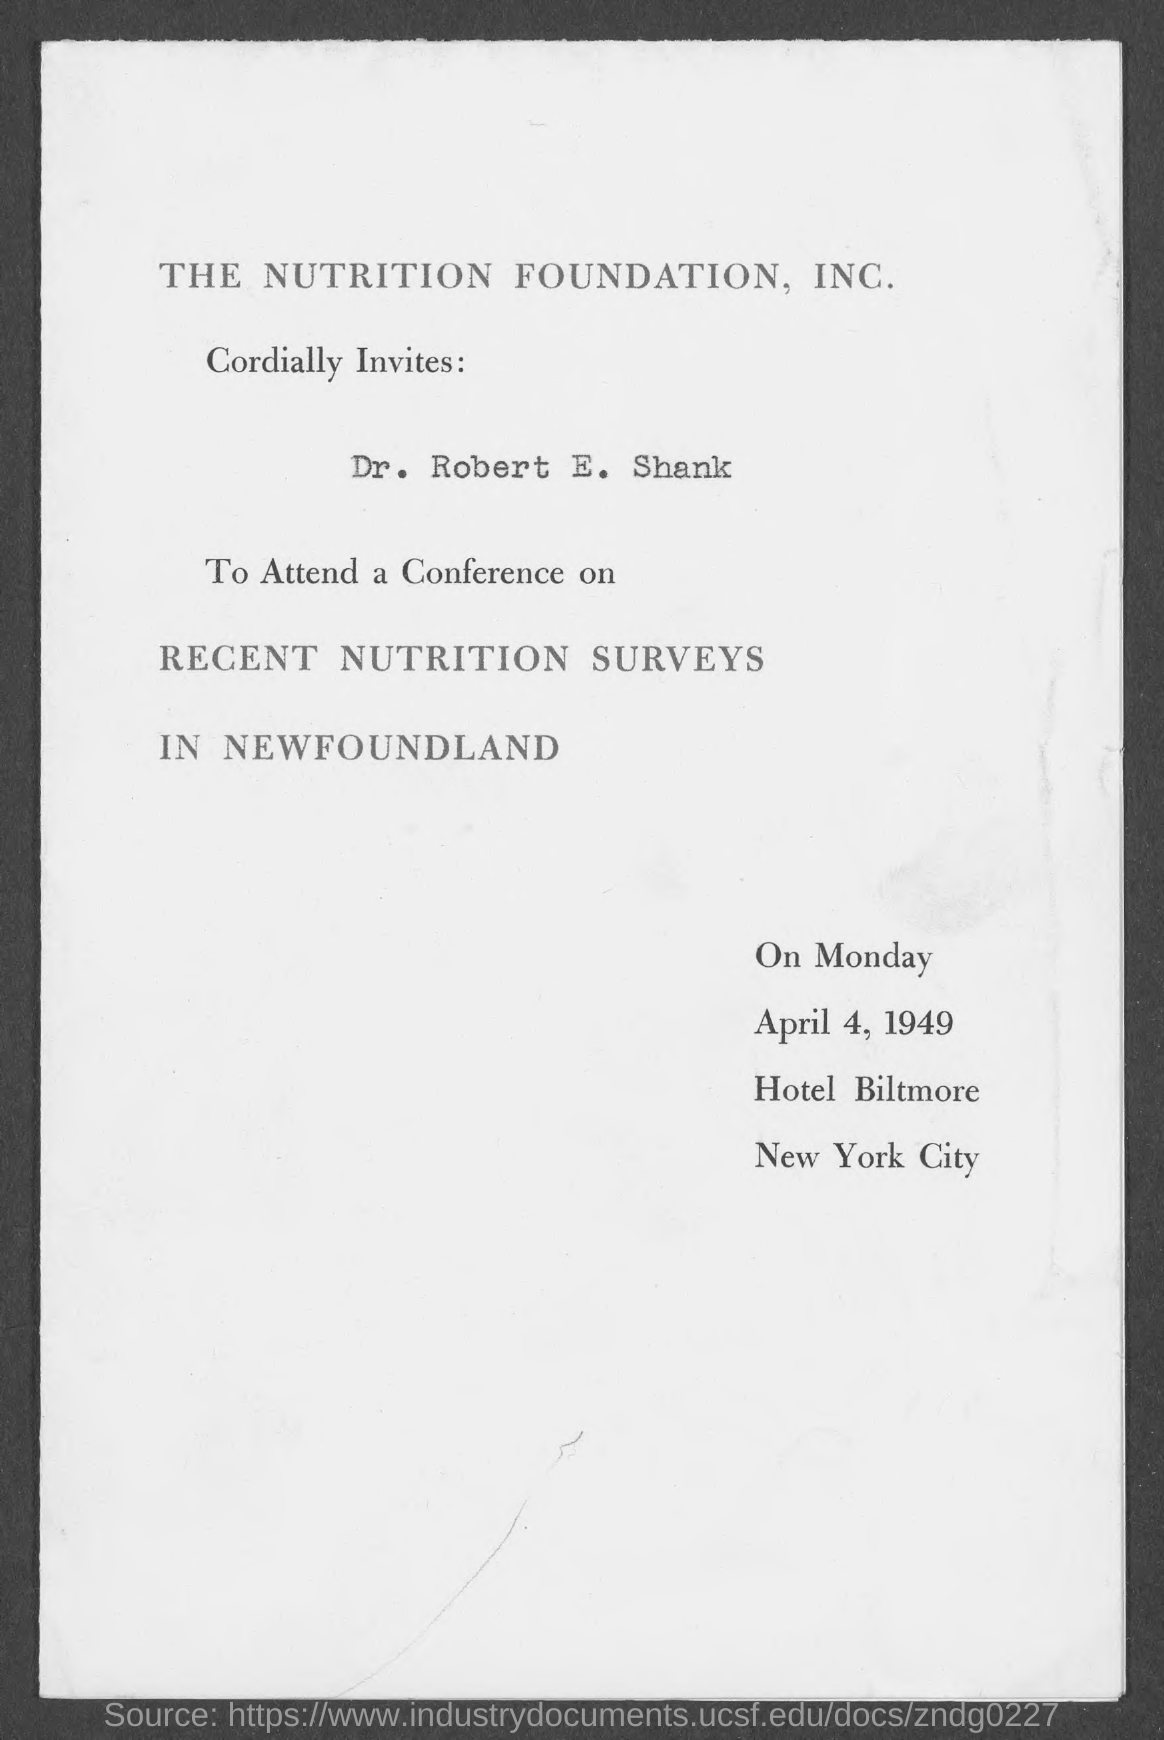Mention a couple of crucial points in this snapshot. The document mentions Monday. 